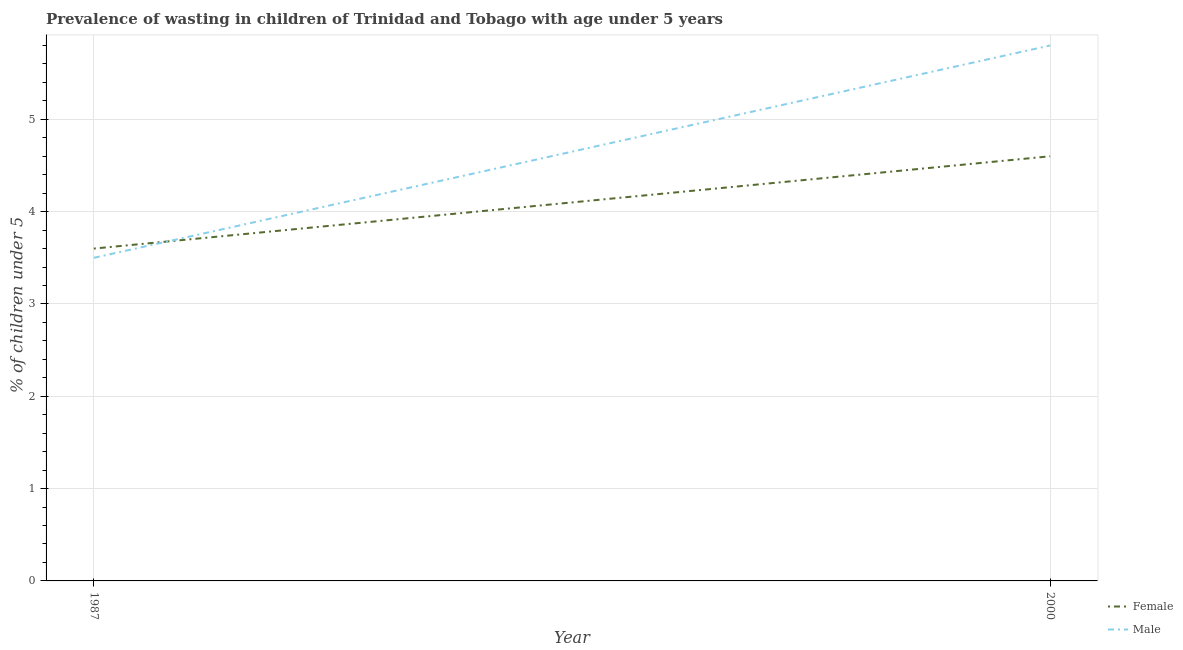How many different coloured lines are there?
Your answer should be compact. 2. Is the number of lines equal to the number of legend labels?
Provide a succinct answer. Yes. What is the percentage of undernourished female children in 1987?
Make the answer very short. 3.6. Across all years, what is the maximum percentage of undernourished female children?
Your answer should be compact. 4.6. Across all years, what is the minimum percentage of undernourished male children?
Provide a short and direct response. 3.5. In which year was the percentage of undernourished female children minimum?
Your answer should be very brief. 1987. What is the total percentage of undernourished female children in the graph?
Your response must be concise. 8.2. What is the difference between the percentage of undernourished male children in 1987 and that in 2000?
Your answer should be compact. -2.3. What is the difference between the percentage of undernourished male children in 1987 and the percentage of undernourished female children in 2000?
Provide a short and direct response. -1.1. What is the average percentage of undernourished male children per year?
Offer a very short reply. 4.65. In the year 1987, what is the difference between the percentage of undernourished female children and percentage of undernourished male children?
Keep it short and to the point. 0.1. In how many years, is the percentage of undernourished male children greater than 5.2 %?
Your answer should be compact. 1. What is the ratio of the percentage of undernourished male children in 1987 to that in 2000?
Your response must be concise. 0.6. Is the percentage of undernourished female children in 1987 less than that in 2000?
Offer a terse response. Yes. Is the percentage of undernourished male children strictly greater than the percentage of undernourished female children over the years?
Offer a terse response. No. Is the percentage of undernourished male children strictly less than the percentage of undernourished female children over the years?
Offer a terse response. No. Are the values on the major ticks of Y-axis written in scientific E-notation?
Ensure brevity in your answer.  No. Does the graph contain grids?
Provide a succinct answer. Yes. Where does the legend appear in the graph?
Provide a succinct answer. Bottom right. How are the legend labels stacked?
Keep it short and to the point. Vertical. What is the title of the graph?
Your answer should be very brief. Prevalence of wasting in children of Trinidad and Tobago with age under 5 years. What is the label or title of the X-axis?
Offer a very short reply. Year. What is the label or title of the Y-axis?
Provide a succinct answer.  % of children under 5. What is the  % of children under 5 in Female in 1987?
Your answer should be very brief. 3.6. What is the  % of children under 5 of Female in 2000?
Your answer should be very brief. 4.6. What is the  % of children under 5 in Male in 2000?
Give a very brief answer. 5.8. Across all years, what is the maximum  % of children under 5 of Female?
Your answer should be compact. 4.6. Across all years, what is the maximum  % of children under 5 of Male?
Make the answer very short. 5.8. Across all years, what is the minimum  % of children under 5 in Female?
Your answer should be very brief. 3.6. Across all years, what is the minimum  % of children under 5 in Male?
Make the answer very short. 3.5. What is the difference between the  % of children under 5 of Male in 1987 and that in 2000?
Make the answer very short. -2.3. What is the difference between the  % of children under 5 in Female in 1987 and the  % of children under 5 in Male in 2000?
Your answer should be very brief. -2.2. What is the average  % of children under 5 in Male per year?
Give a very brief answer. 4.65. What is the ratio of the  % of children under 5 in Female in 1987 to that in 2000?
Your response must be concise. 0.78. What is the ratio of the  % of children under 5 in Male in 1987 to that in 2000?
Your answer should be compact. 0.6. What is the difference between the highest and the second highest  % of children under 5 of Female?
Keep it short and to the point. 1. What is the difference between the highest and the lowest  % of children under 5 in Female?
Provide a short and direct response. 1. What is the difference between the highest and the lowest  % of children under 5 of Male?
Provide a short and direct response. 2.3. 